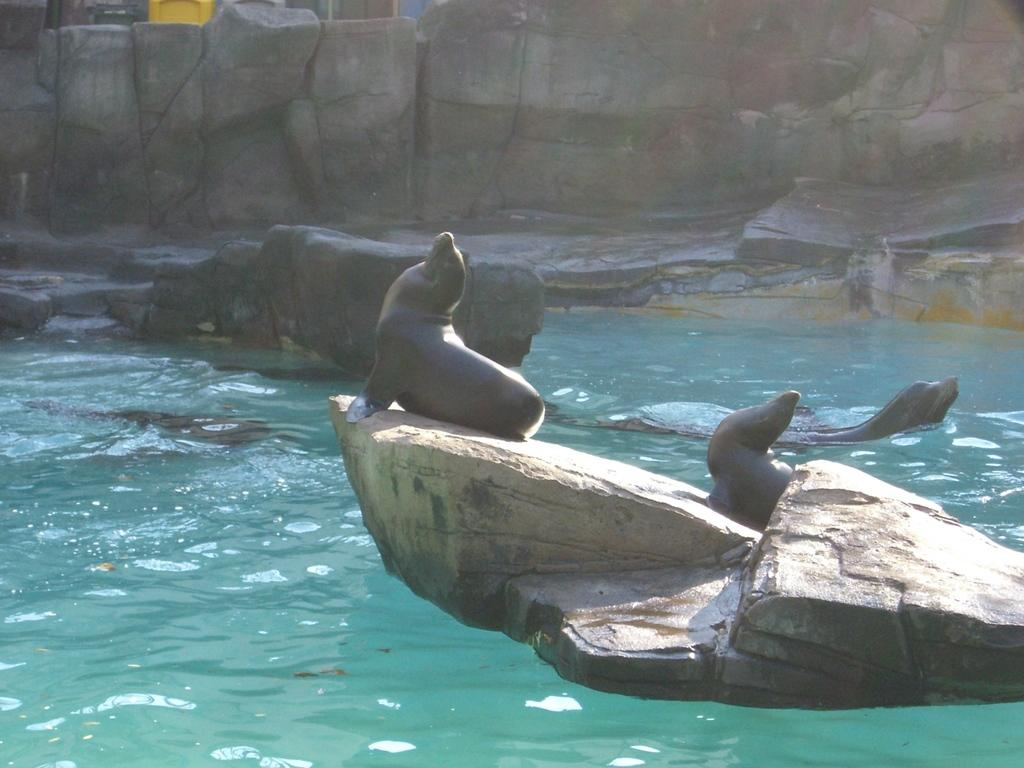What animals are present in the image? There are dolphins in the image. How many dolphins are on a rock in the image? Two dolphins are on a rock in the image. How many dolphins are in the water in the image? Two dolphins are in the water in the image. What can be seen in the background of the image? There are rocks visible in the background of the image. What type of produce can be seen growing on the rocks in the image? There is no produce visible in the image; it features dolphins on a rock and in the water, with rocks in the background. 